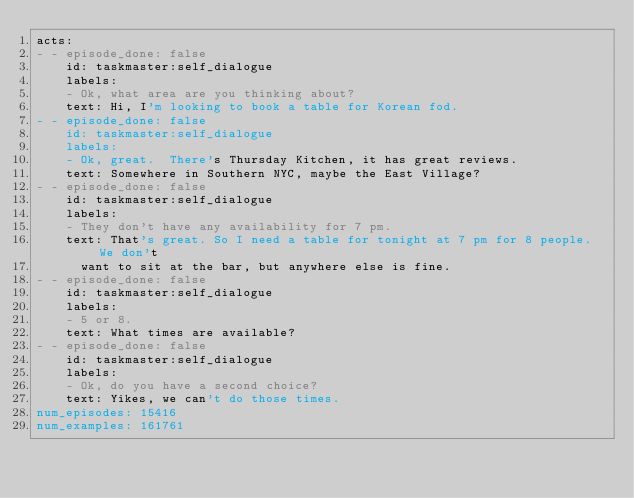Convert code to text. <code><loc_0><loc_0><loc_500><loc_500><_YAML_>acts:
- - episode_done: false
    id: taskmaster:self_dialogue
    labels:
    - Ok, what area are you thinking about?
    text: Hi, I'm looking to book a table for Korean fod.
- - episode_done: false
    id: taskmaster:self_dialogue
    labels:
    - Ok, great.  There's Thursday Kitchen, it has great reviews.
    text: Somewhere in Southern NYC, maybe the East Village?
- - episode_done: false
    id: taskmaster:self_dialogue
    labels:
    - They don't have any availability for 7 pm.
    text: That's great. So I need a table for tonight at 7 pm for 8 people. We don't
      want to sit at the bar, but anywhere else is fine.
- - episode_done: false
    id: taskmaster:self_dialogue
    labels:
    - 5 or 8.
    text: What times are available?
- - episode_done: false
    id: taskmaster:self_dialogue
    labels:
    - Ok, do you have a second choice?
    text: Yikes, we can't do those times.
num_episodes: 15416
num_examples: 161761
</code> 